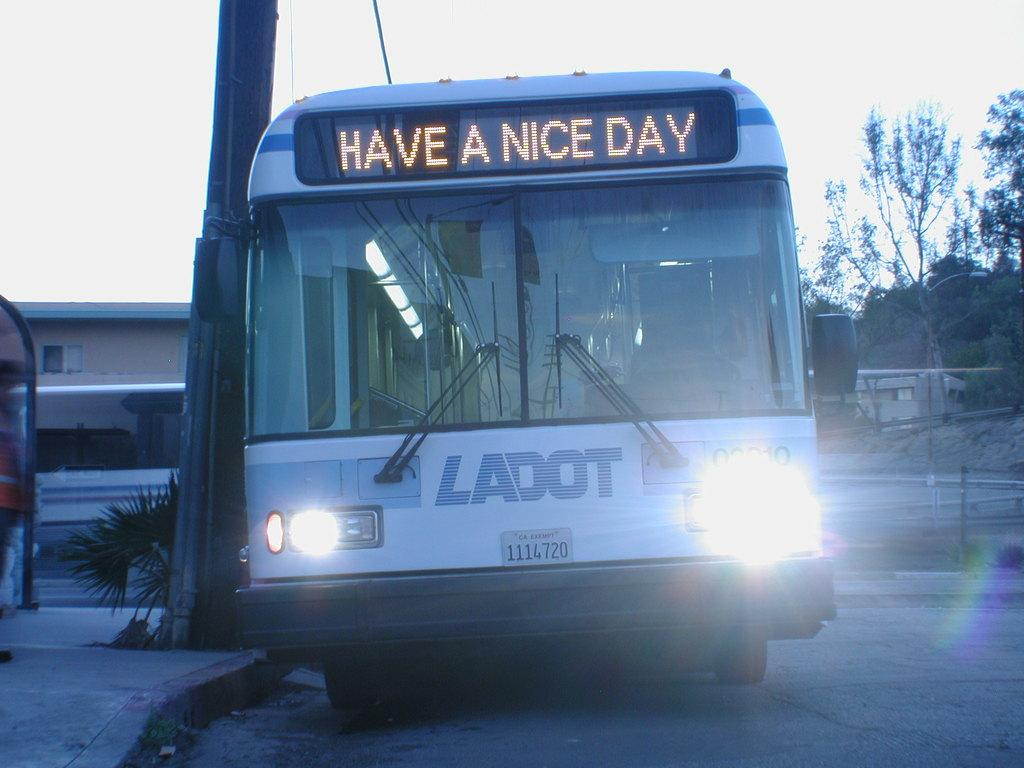<image>
Give a short and clear explanation of the subsequent image. a bus labeled 'ladot' with the words 'have a nice day' on the front screen 